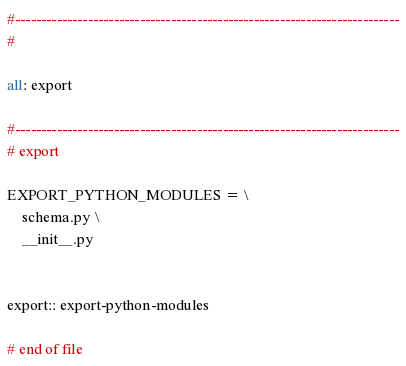<code> <loc_0><loc_0><loc_500><loc_500><_ObjectiveC_>

#--------------------------------------------------------------------------
#

all: export

#--------------------------------------------------------------------------
# export

EXPORT_PYTHON_MODULES = \
    schema.py \
    __init__.py


export:: export-python-modules

# end of file
</code> 